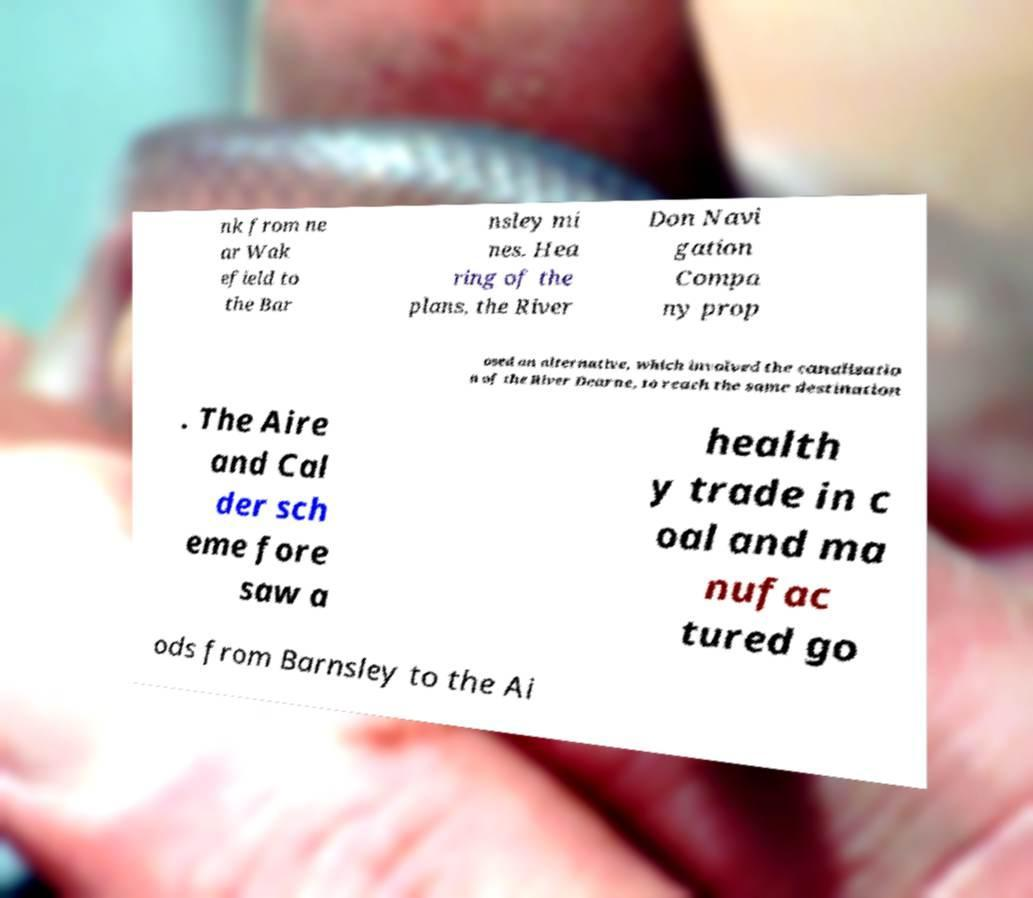Could you extract and type out the text from this image? nk from ne ar Wak efield to the Bar nsley mi nes. Hea ring of the plans, the River Don Navi gation Compa ny prop osed an alternative, which involved the canalisatio n of the River Dearne, to reach the same destination . The Aire and Cal der sch eme fore saw a health y trade in c oal and ma nufac tured go ods from Barnsley to the Ai 